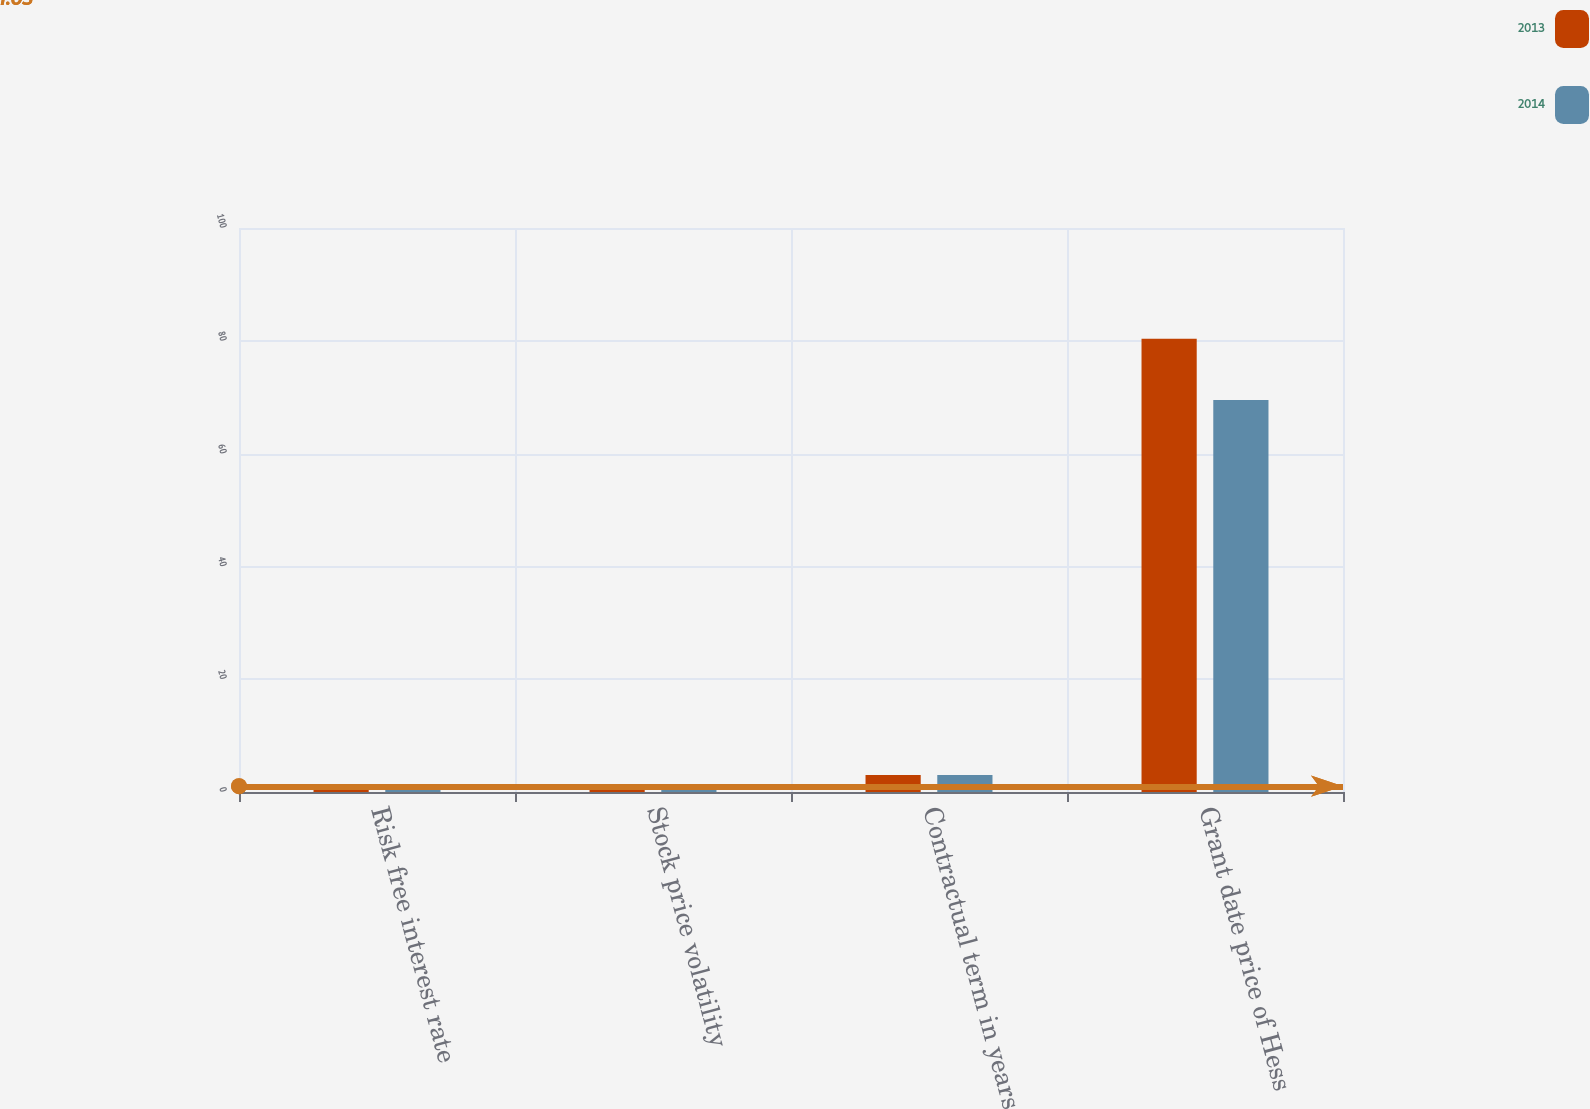Convert chart. <chart><loc_0><loc_0><loc_500><loc_500><stacked_bar_chart><ecel><fcel>Risk free interest rate<fcel>Stock price volatility<fcel>Contractual term in years<fcel>Grant date price of Hess<nl><fcel>2013<fcel>0.65<fcel>0.36<fcel>3<fcel>80.35<nl><fcel>2014<fcel>0.36<fcel>0.36<fcel>3<fcel>69.49<nl></chart> 